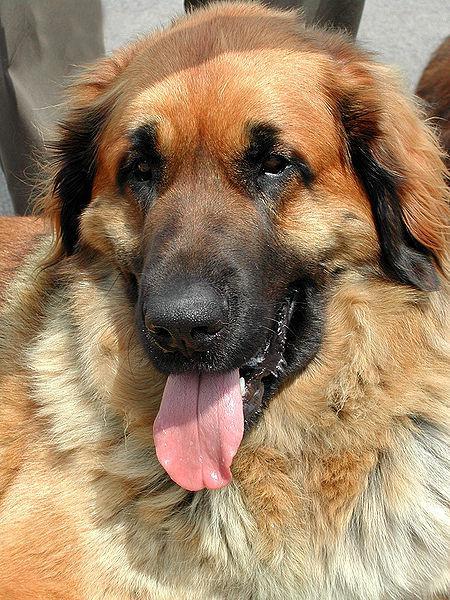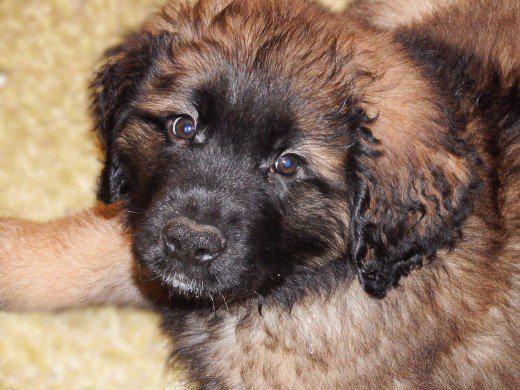The first image is the image on the left, the second image is the image on the right. Given the left and right images, does the statement "The dog in one of the images is lying down on the carpet." hold true? Answer yes or no. Yes. The first image is the image on the left, the second image is the image on the right. Considering the images on both sides, is "The dogs in the two images are looking in the same direction, and no dog has its tongue showing." valid? Answer yes or no. No. 